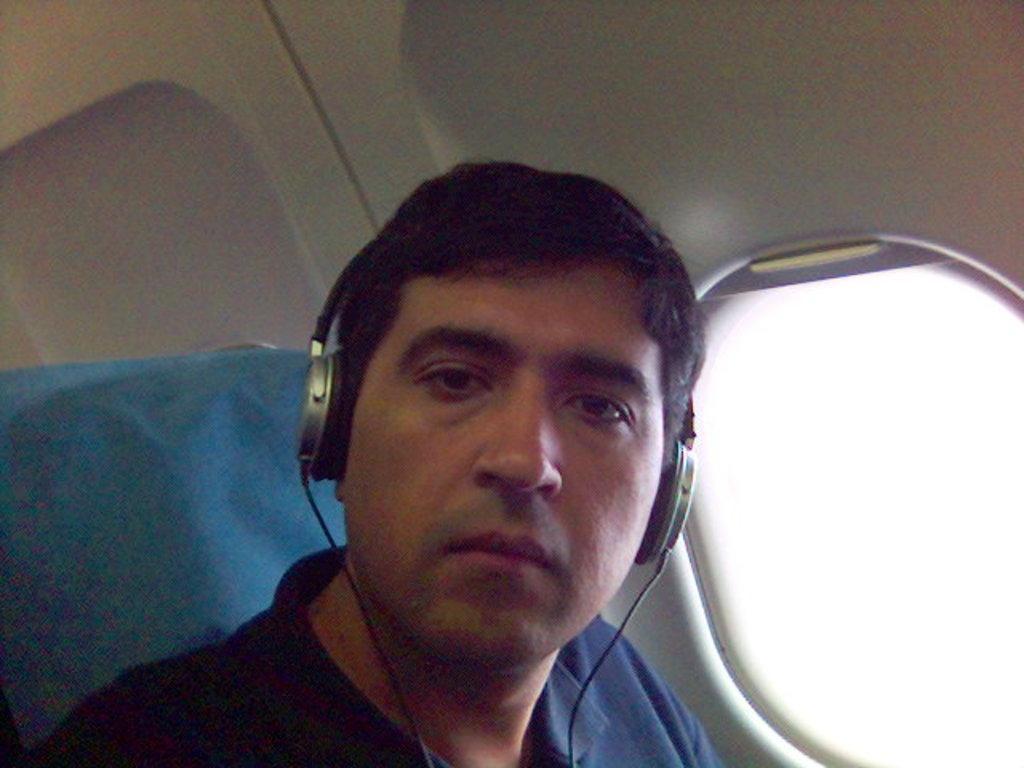Could you give a brief overview of what you see in this image? In this picture we can see the man wearing blue t-shirt is sitting in the flight and looking into the camera. Behind we can see the flight cabin and window. 